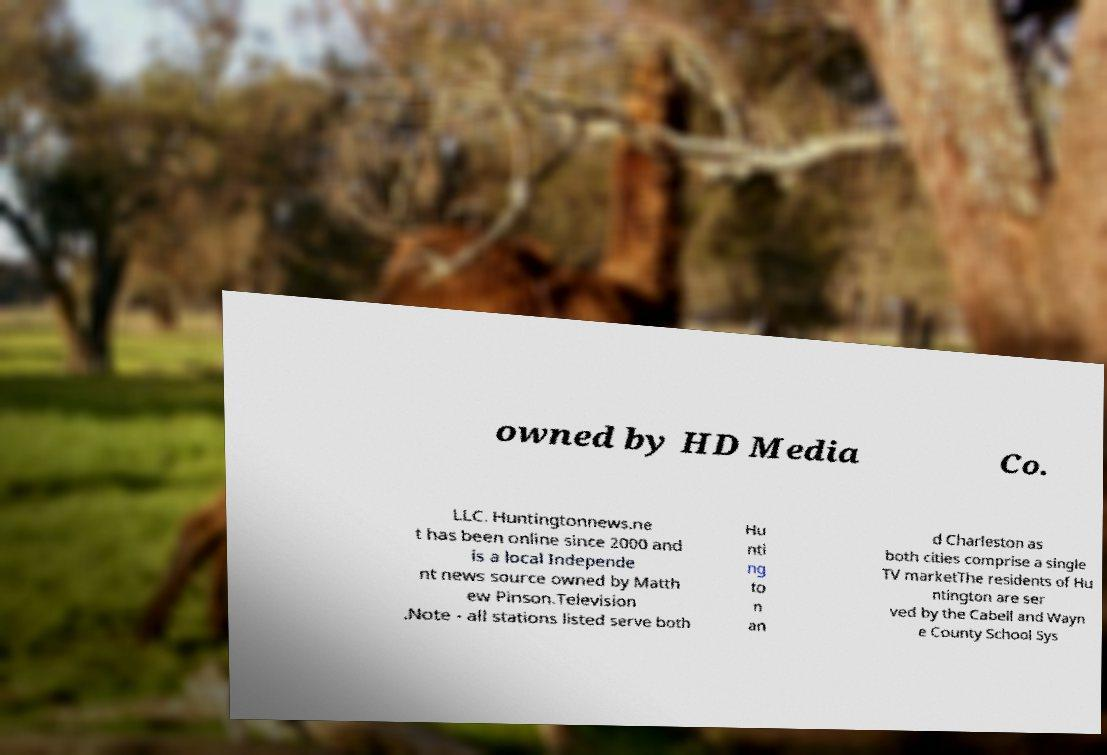For documentation purposes, I need the text within this image transcribed. Could you provide that? owned by HD Media Co. LLC. Huntingtonnews.ne t has been online since 2000 and is a local Independe nt news source owned by Matth ew Pinson.Television .Note - all stations listed serve both Hu nti ng to n an d Charleston as both cities comprise a single TV marketThe residents of Hu ntington are ser ved by the Cabell and Wayn e County School Sys 